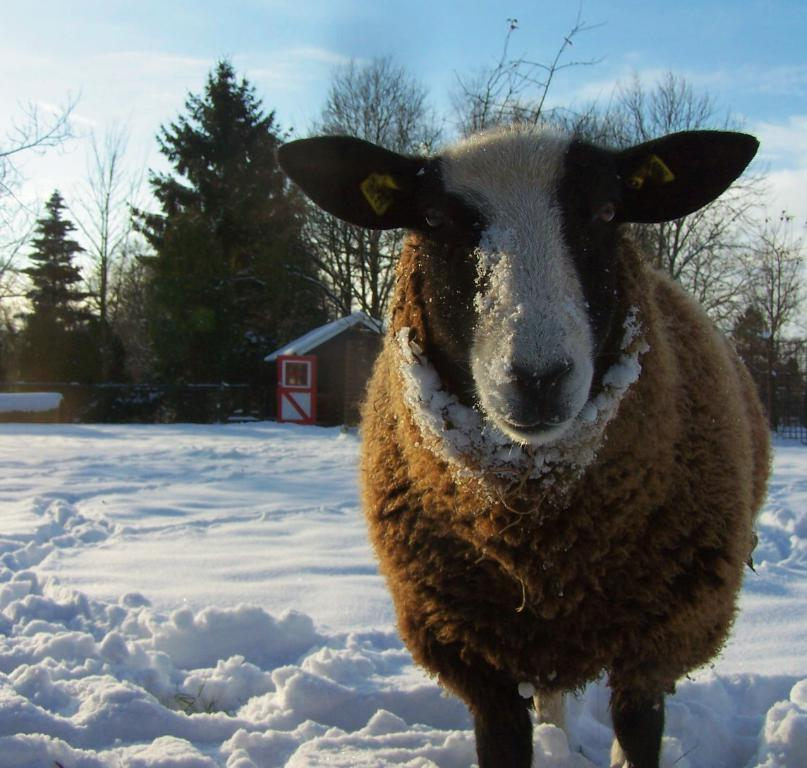What type of animal can be seen in the image? There is an animal in the image, but its specific type cannot be determined from the provided facts. What structure is present in the image? There is a house in the image. What type of vegetation is visible in the image? There are trees in the image. What is the weather like in the image? The presence of snow in the image suggests a cold or wintery environment. What is visible in the background of the image? The sky is visible in the background of the image. What page number is the animal reading in the image? There is no indication in the image that the animal is reading a book or any other written material, so it cannot be determined from the image. 